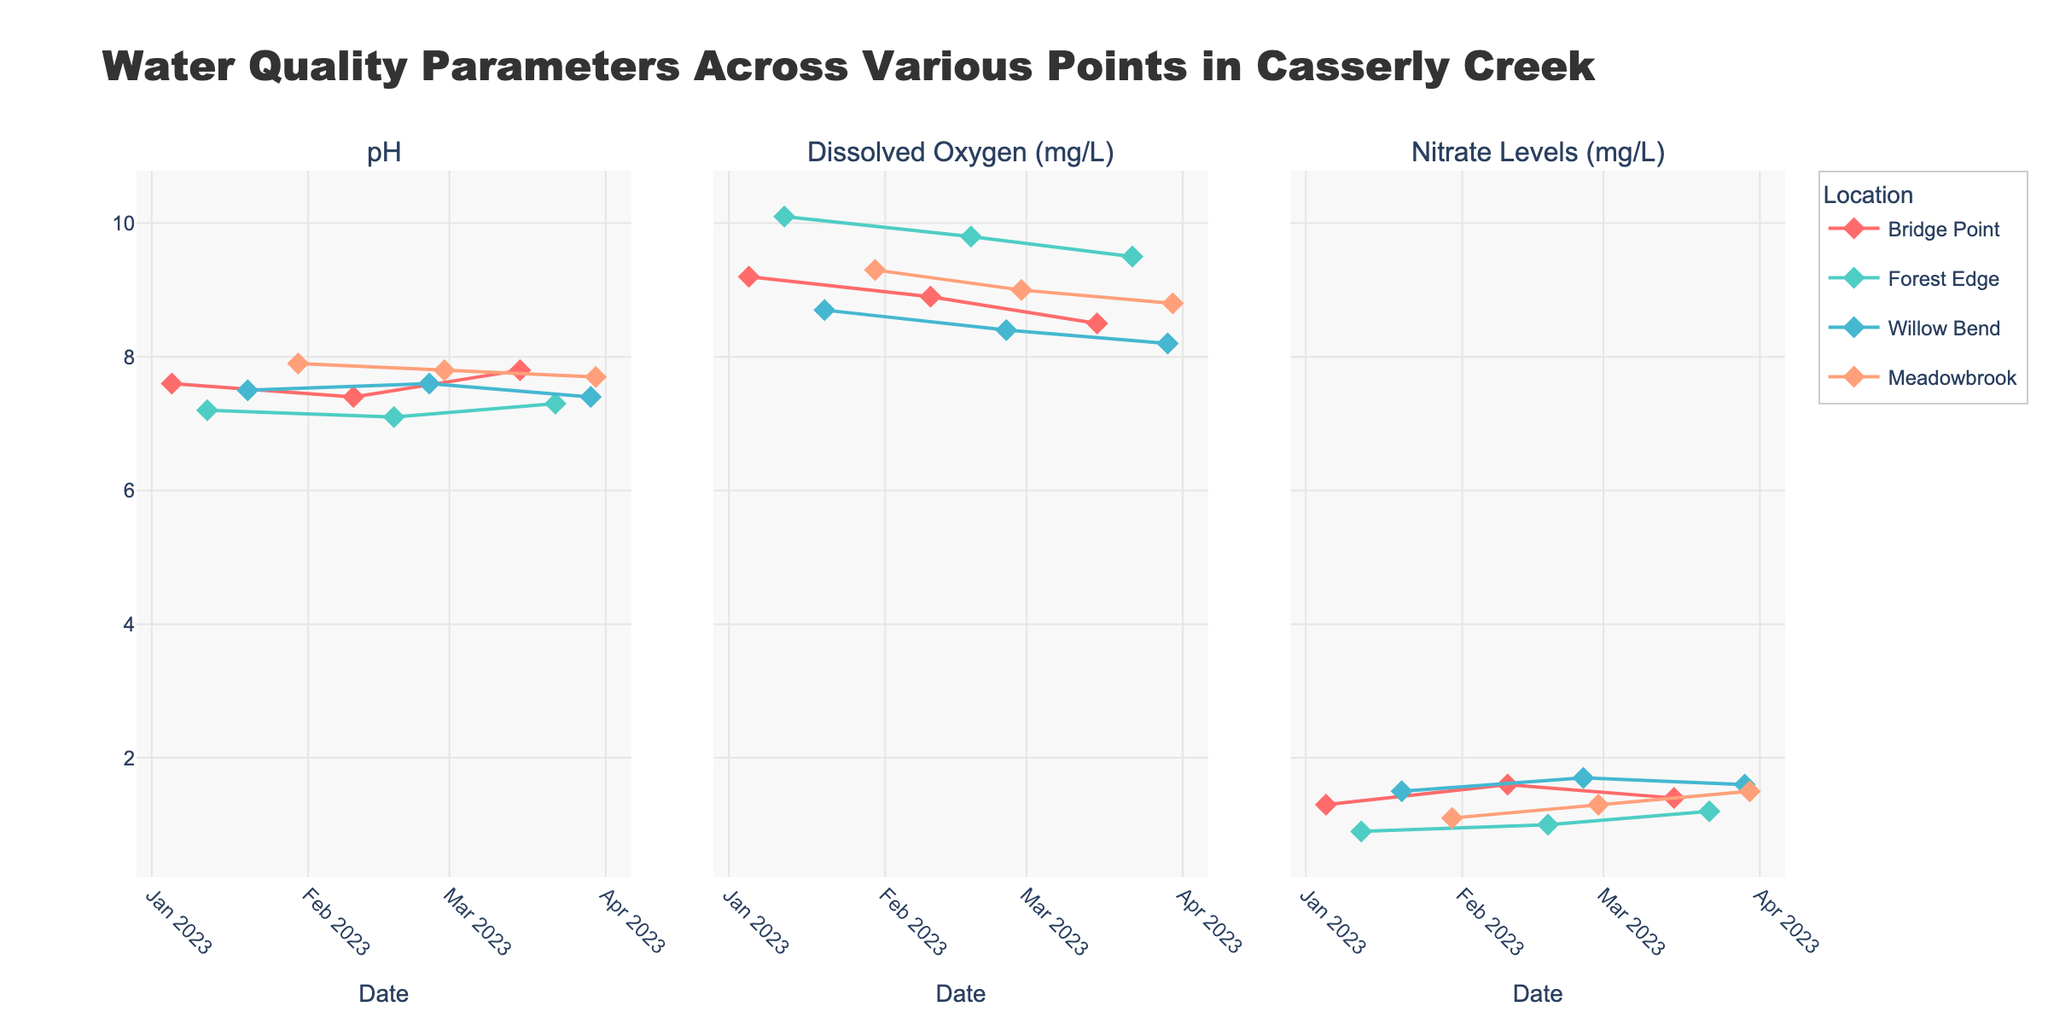What's the flow of pH values at Bridge Point over time? The line for pH values at Bridge Point shows markers for data points taken over time. Look at the positions of these markers from January to March, noting the numeric pH values placed at each point.
Answer: 7.6, 7.4, 7.8 How do nitrate levels at Willow Bend compare between January and March 2023? At Willow Bend, observe the data points for nitrate levels in January and March. Compare the positions of these markers to see how they align vertically (higher values).
Answer: 1.5 in January; 1.6 in March Which location shows the highest dissolved oxygen level in January 2023? Locate the dissolved oxygen levels for January across all locations. Identify which marker is the highest on the y-axis.
Answer: Forest Edge (10.1 mg/L) What's the trend in nitrate levels at Meadowbrook from January to March 2023? Observe the nitrate level markers for Meadowbrook from January through March. Note whether the points increase, decrease, or remain stable over time.
Answer: Increasing trend (1.1 to 1.5 mg/L) Which location has the most stable pH values over time? Examine the pH value markers for each location from January to March. Compare the variations between markers at each location to see which has the smallest range of change.
Answer: Forest Edge What's the average dissolved oxygen level at Bridge Point across the given data points? For each data point at Bridge Point, sum the dissolved oxygen values and divide by the number of data points. (9.2 + 8.9 + 8.5) / 3 = 8.867
Answer: 8.867 mg/L Is the pH level at Forest Edge higher or lower than Willow Bend in March 2023? Compare the markers for pH levels at Forest Edge and Willow Bend for March 2023. Observe the position on the y-axis.
Answer: Lower (7.3 at Forest Edge; 7.4 at Willow Bend) Between January and March 2023, which location shows the largest increase in pH value? Subtract the pH value for January from the value for March for each location, and compare the differences.
Answer: Bridge Point (0.2 increase) What is the general trend in dissolved oxygen levels at Forest Edge? Look at all markers for dissolved oxygen at Forest Edge from January to March. Note if they are rising, falling, or staying the same over time.
Answer: Decreasing trend Is there any location where nitrate levels remain constant over the time period? Inspect the nitrate level markers for all locations from January through March. Determine if any location shows the same value at each data point.
Answer: No, all locations show changes each month 